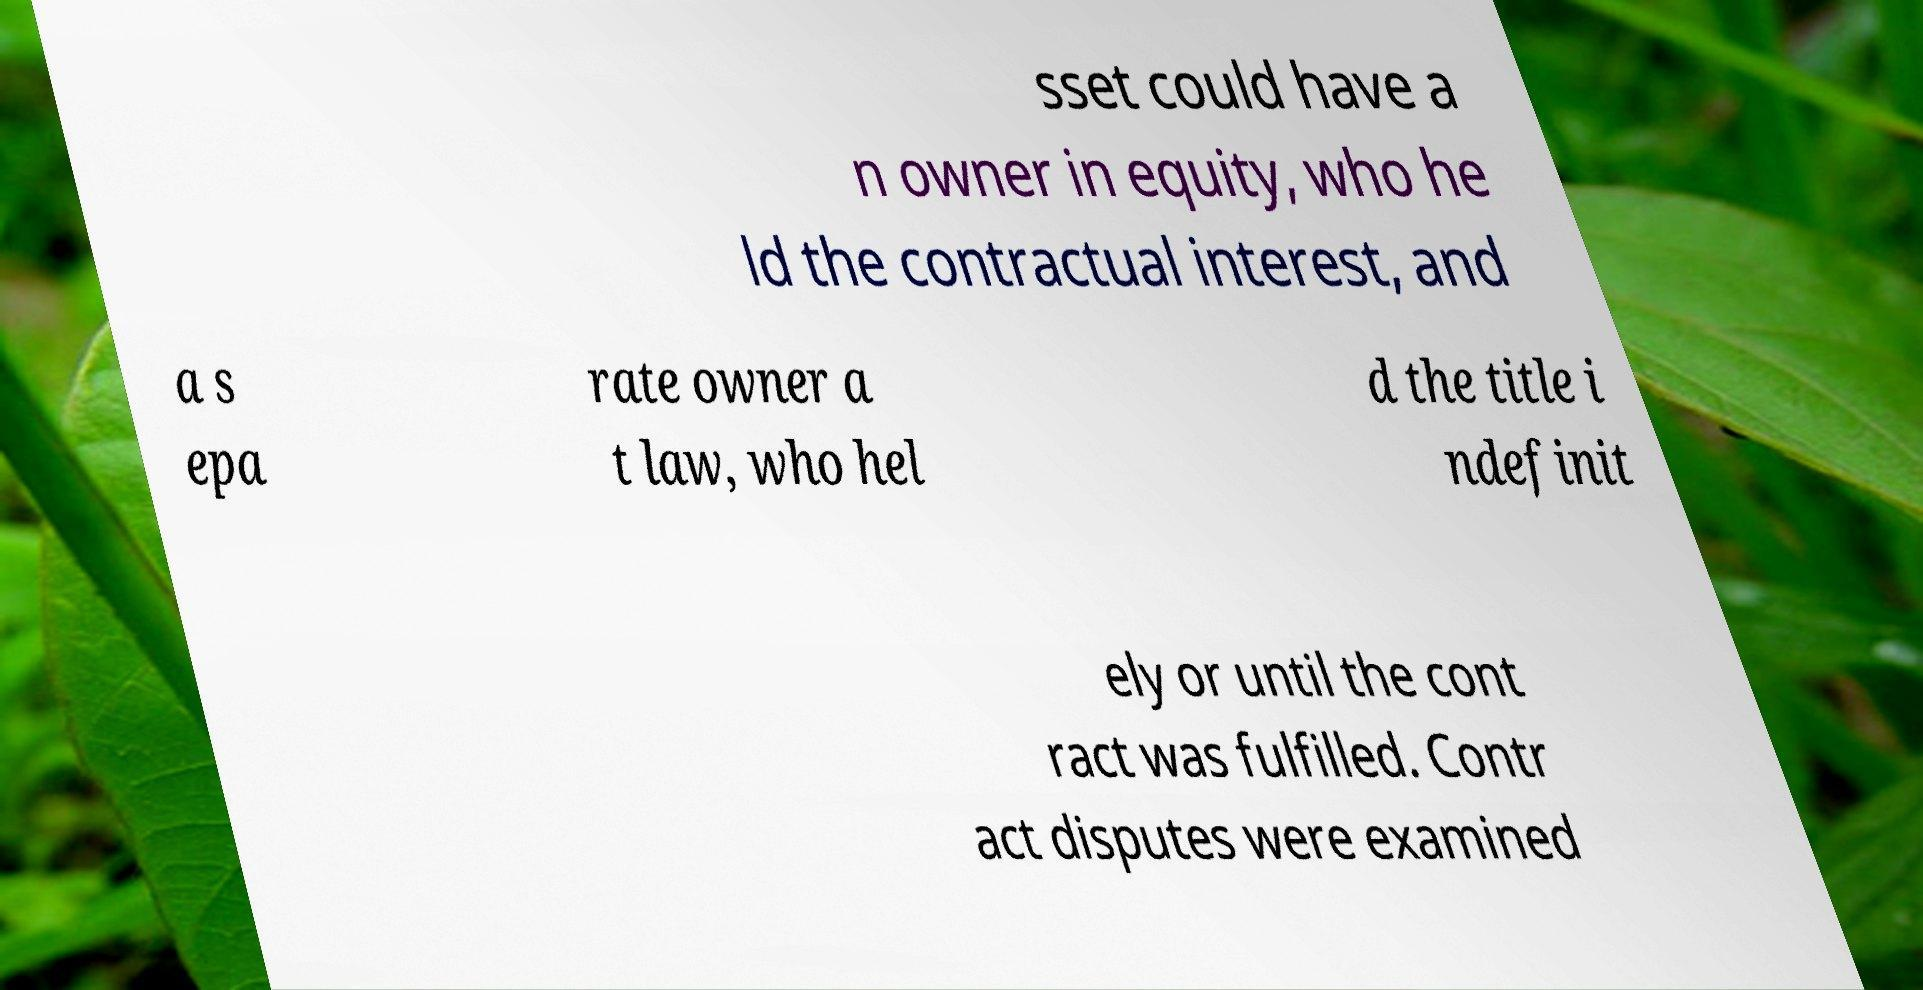Please identify and transcribe the text found in this image. sset could have a n owner in equity, who he ld the contractual interest, and a s epa rate owner a t law, who hel d the title i ndefinit ely or until the cont ract was fulfilled. Contr act disputes were examined 